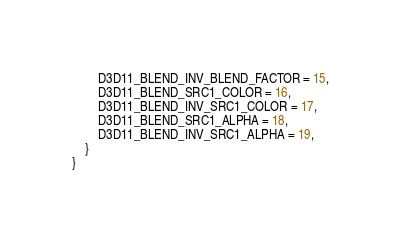<code> <loc_0><loc_0><loc_500><loc_500><_C#_>        D3D11_BLEND_INV_BLEND_FACTOR = 15,
        D3D11_BLEND_SRC1_COLOR = 16,
        D3D11_BLEND_INV_SRC1_COLOR = 17,
        D3D11_BLEND_SRC1_ALPHA = 18,
        D3D11_BLEND_INV_SRC1_ALPHA = 19,
    }
}
</code> 